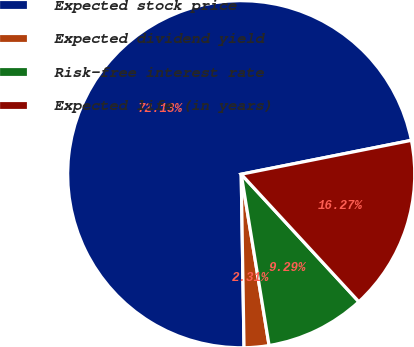Convert chart. <chart><loc_0><loc_0><loc_500><loc_500><pie_chart><fcel>Expected stock price<fcel>Expected dividend yield<fcel>Risk-free interest rate<fcel>Expected life (in years)<nl><fcel>72.13%<fcel>2.31%<fcel>9.29%<fcel>16.27%<nl></chart> 